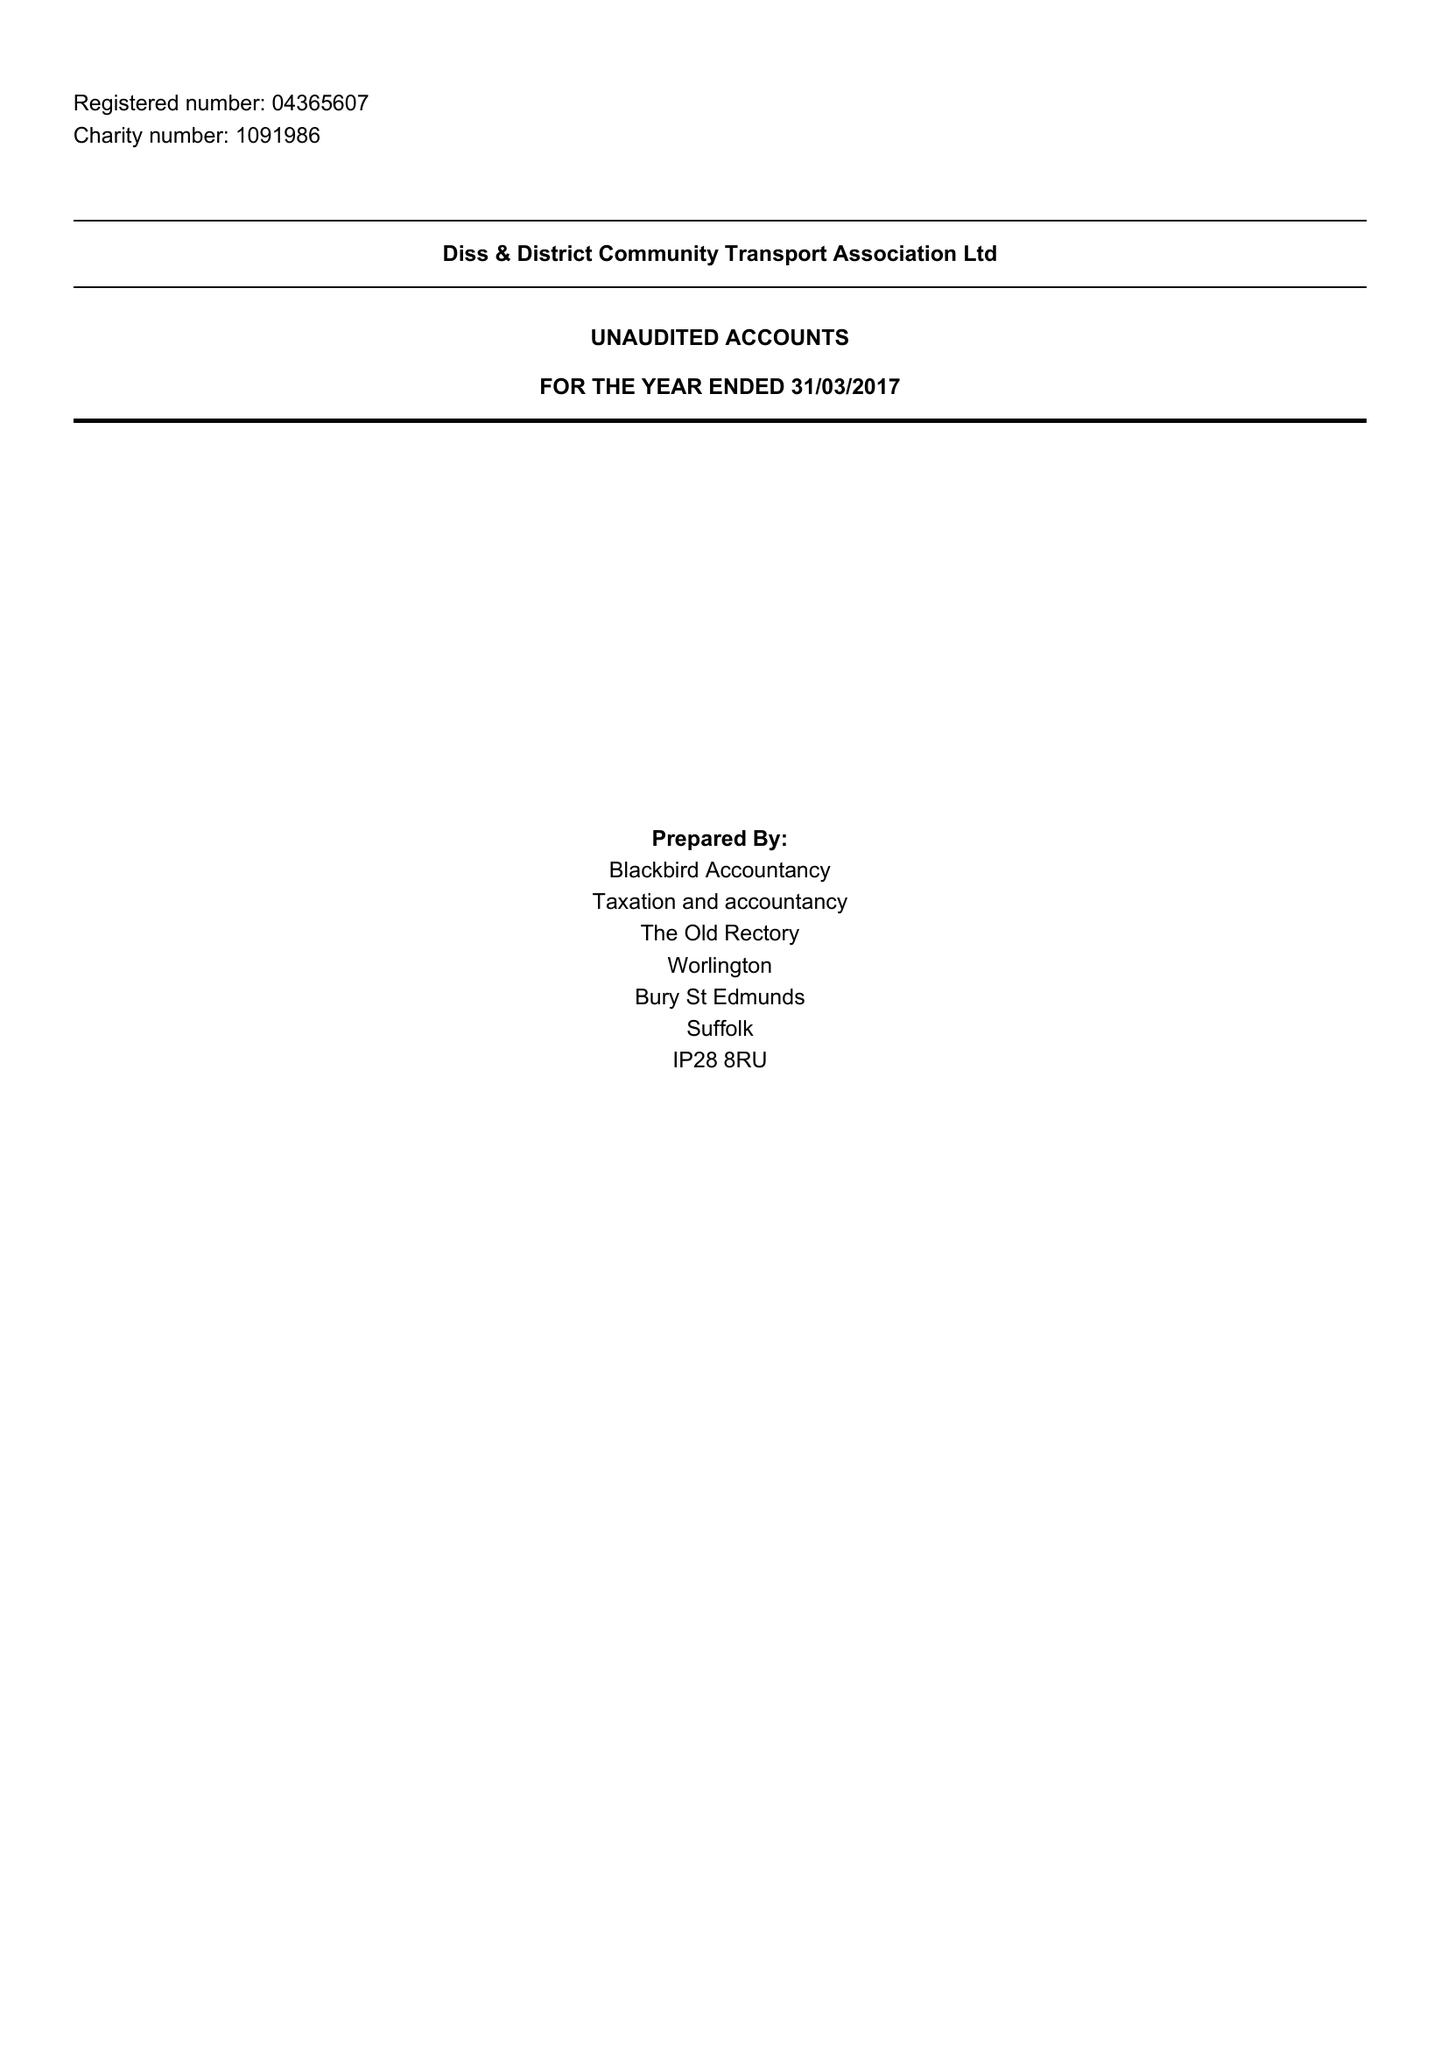What is the value for the address__street_line?
Answer the question using a single word or phrase. THE STREET 